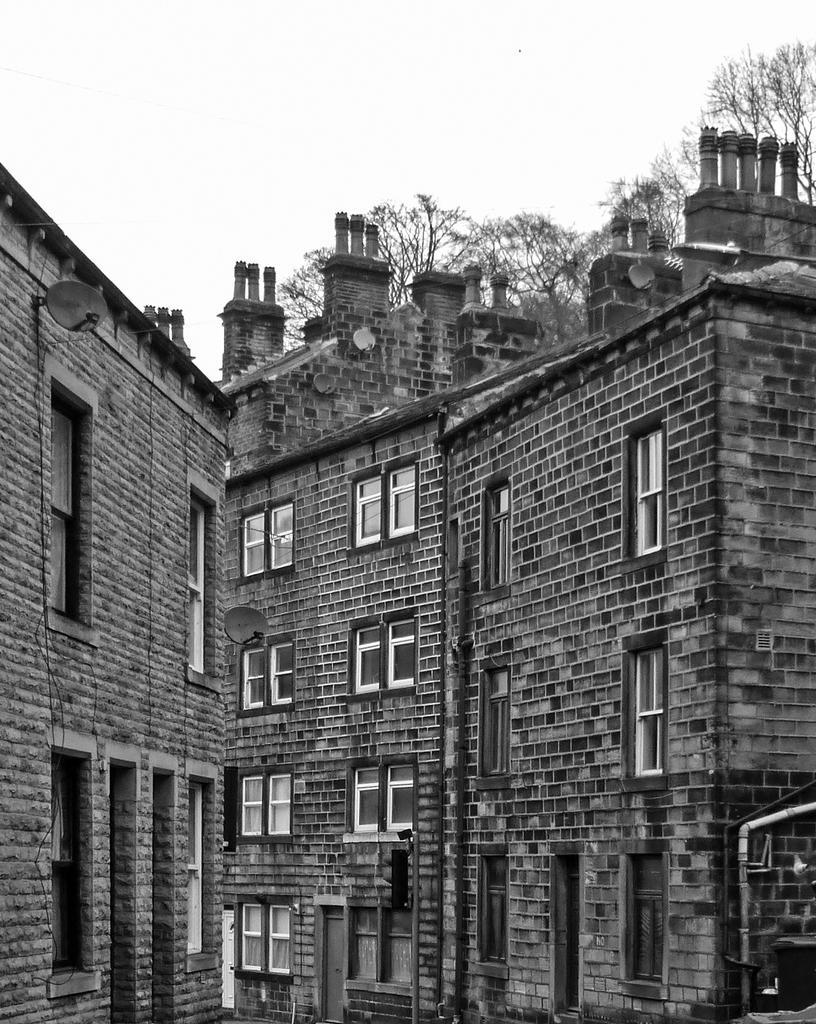Could you give a brief overview of what you see in this image? In this picture I can observe buildings. In the background there are trees and sky. This is a black and white image. 